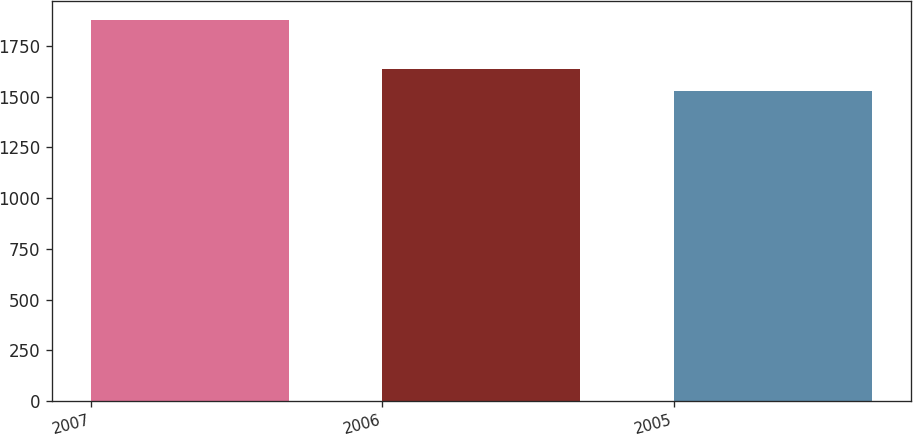Convert chart to OTSL. <chart><loc_0><loc_0><loc_500><loc_500><bar_chart><fcel>2007<fcel>2006<fcel>2005<nl><fcel>1876<fcel>1636<fcel>1530<nl></chart> 